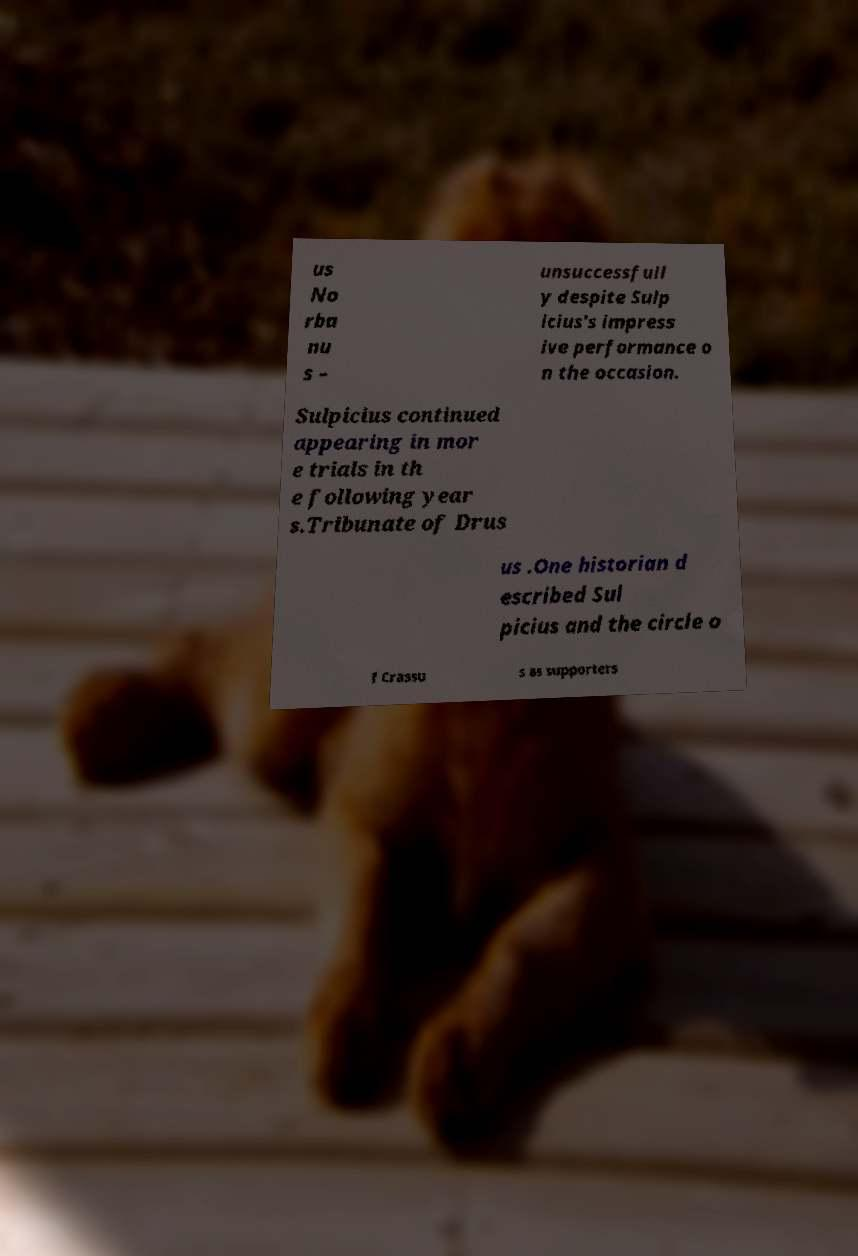For documentation purposes, I need the text within this image transcribed. Could you provide that? us No rba nu s – unsuccessfull y despite Sulp icius's impress ive performance o n the occasion. Sulpicius continued appearing in mor e trials in th e following year s.Tribunate of Drus us .One historian d escribed Sul picius and the circle o f Crassu s as supporters 